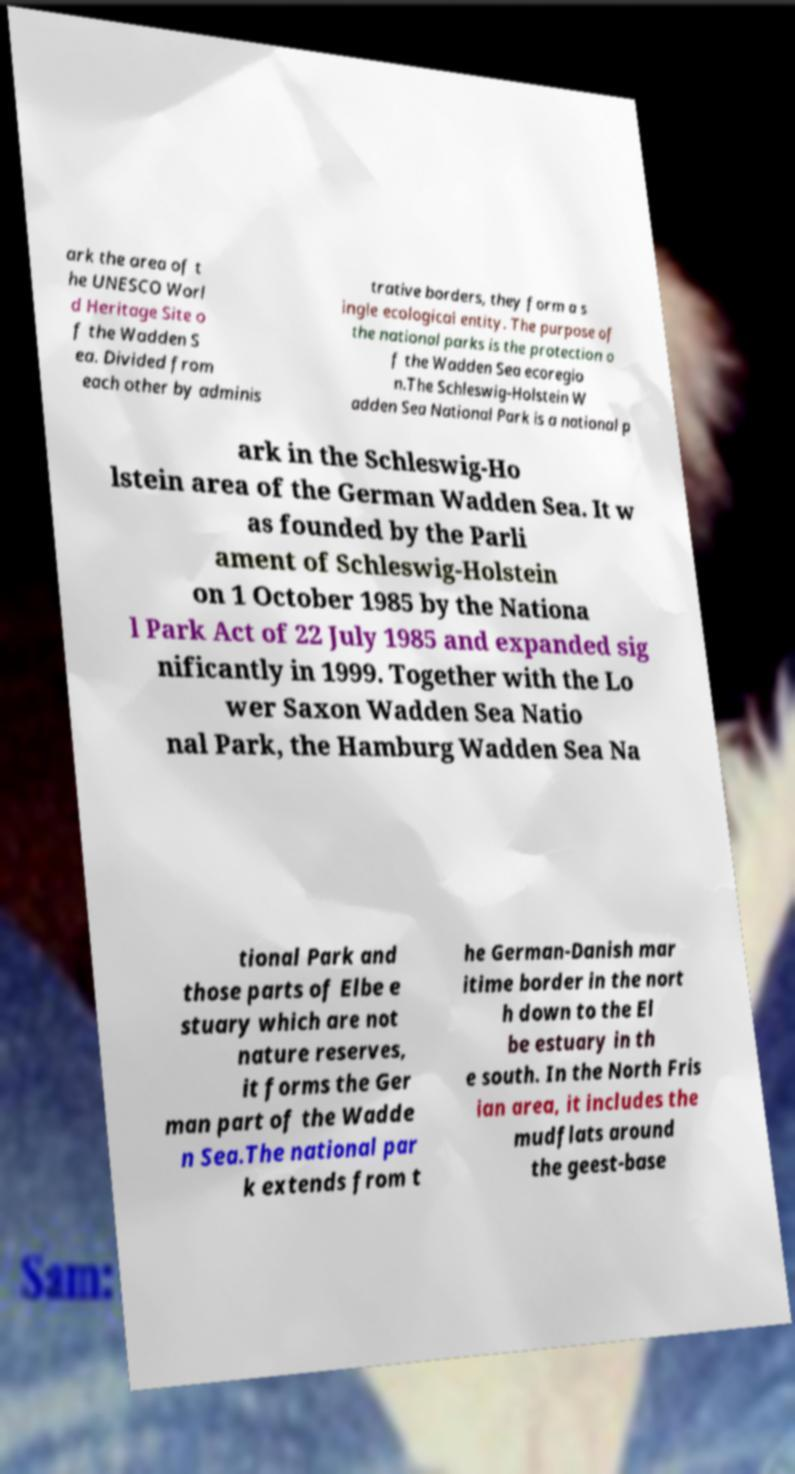Can you read and provide the text displayed in the image?This photo seems to have some interesting text. Can you extract and type it out for me? ark the area of t he UNESCO Worl d Heritage Site o f the Wadden S ea. Divided from each other by adminis trative borders, they form a s ingle ecological entity. The purpose of the national parks is the protection o f the Wadden Sea ecoregio n.The Schleswig-Holstein W adden Sea National Park is a national p ark in the Schleswig-Ho lstein area of the German Wadden Sea. It w as founded by the Parli ament of Schleswig-Holstein on 1 October 1985 by the Nationa l Park Act of 22 July 1985 and expanded sig nificantly in 1999. Together with the Lo wer Saxon Wadden Sea Natio nal Park, the Hamburg Wadden Sea Na tional Park and those parts of Elbe e stuary which are not nature reserves, it forms the Ger man part of the Wadde n Sea.The national par k extends from t he German-Danish mar itime border in the nort h down to the El be estuary in th e south. In the North Fris ian area, it includes the mudflats around the geest-base 